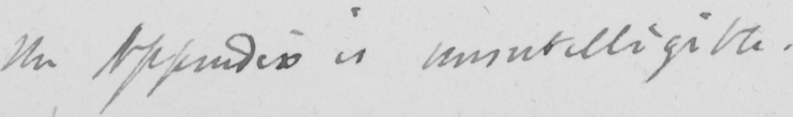What is written in this line of handwriting? the Appendix is unintelligible . 